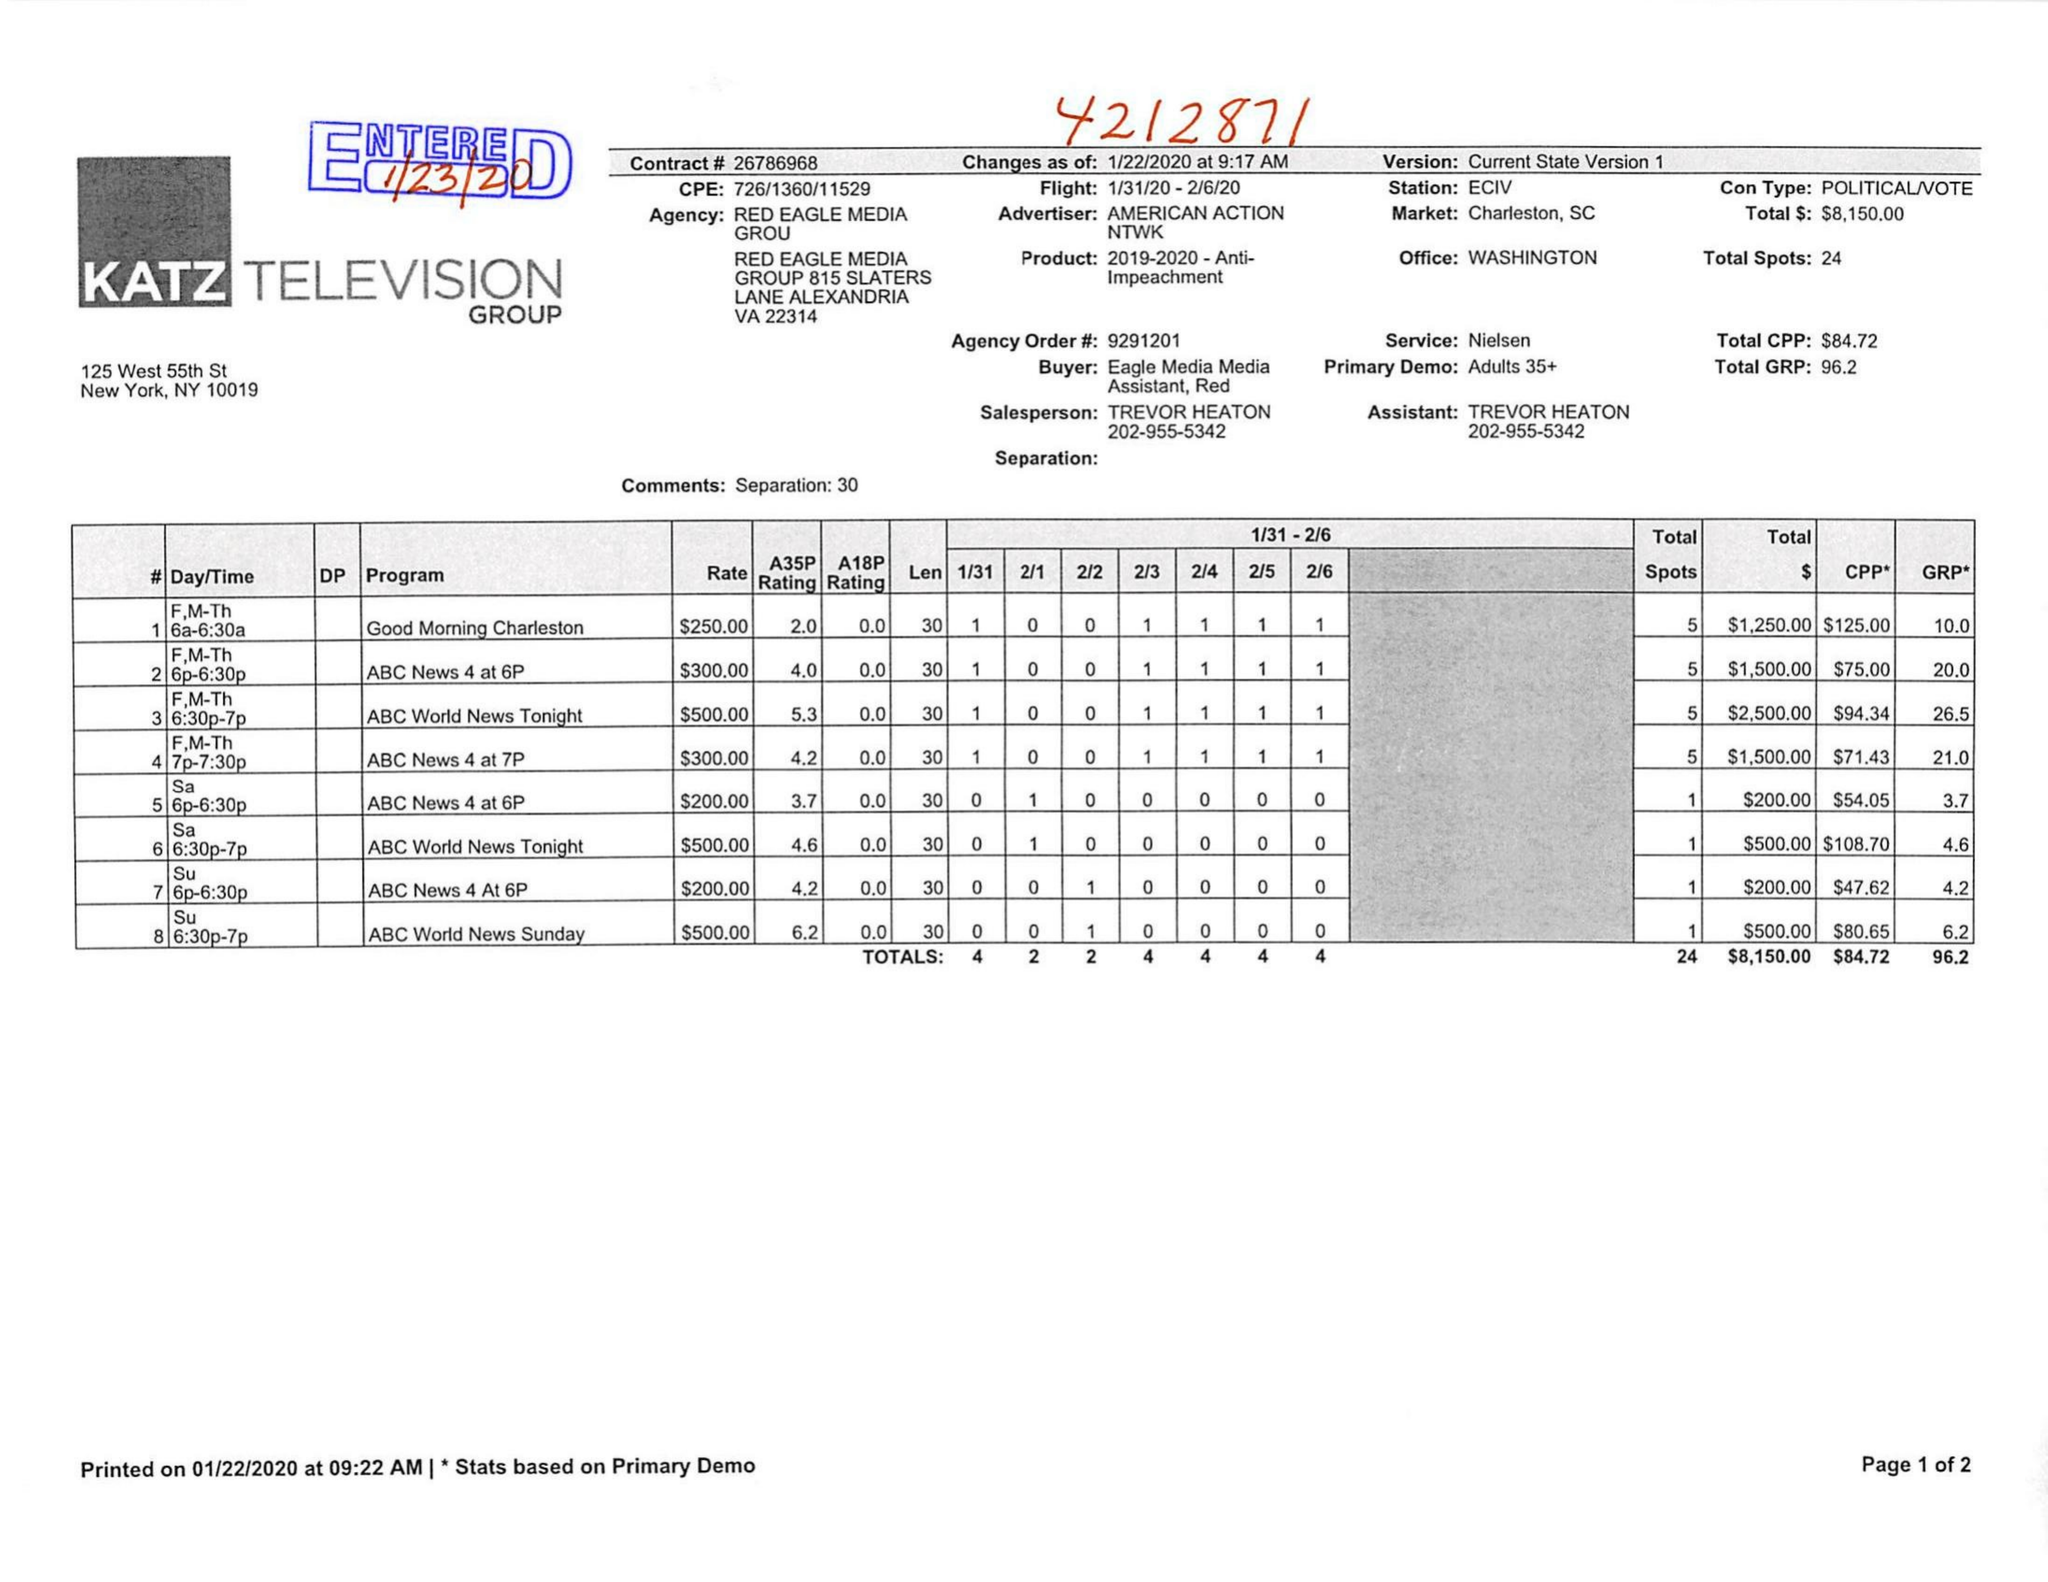What is the value for the contract_num?
Answer the question using a single word or phrase. 6786968 